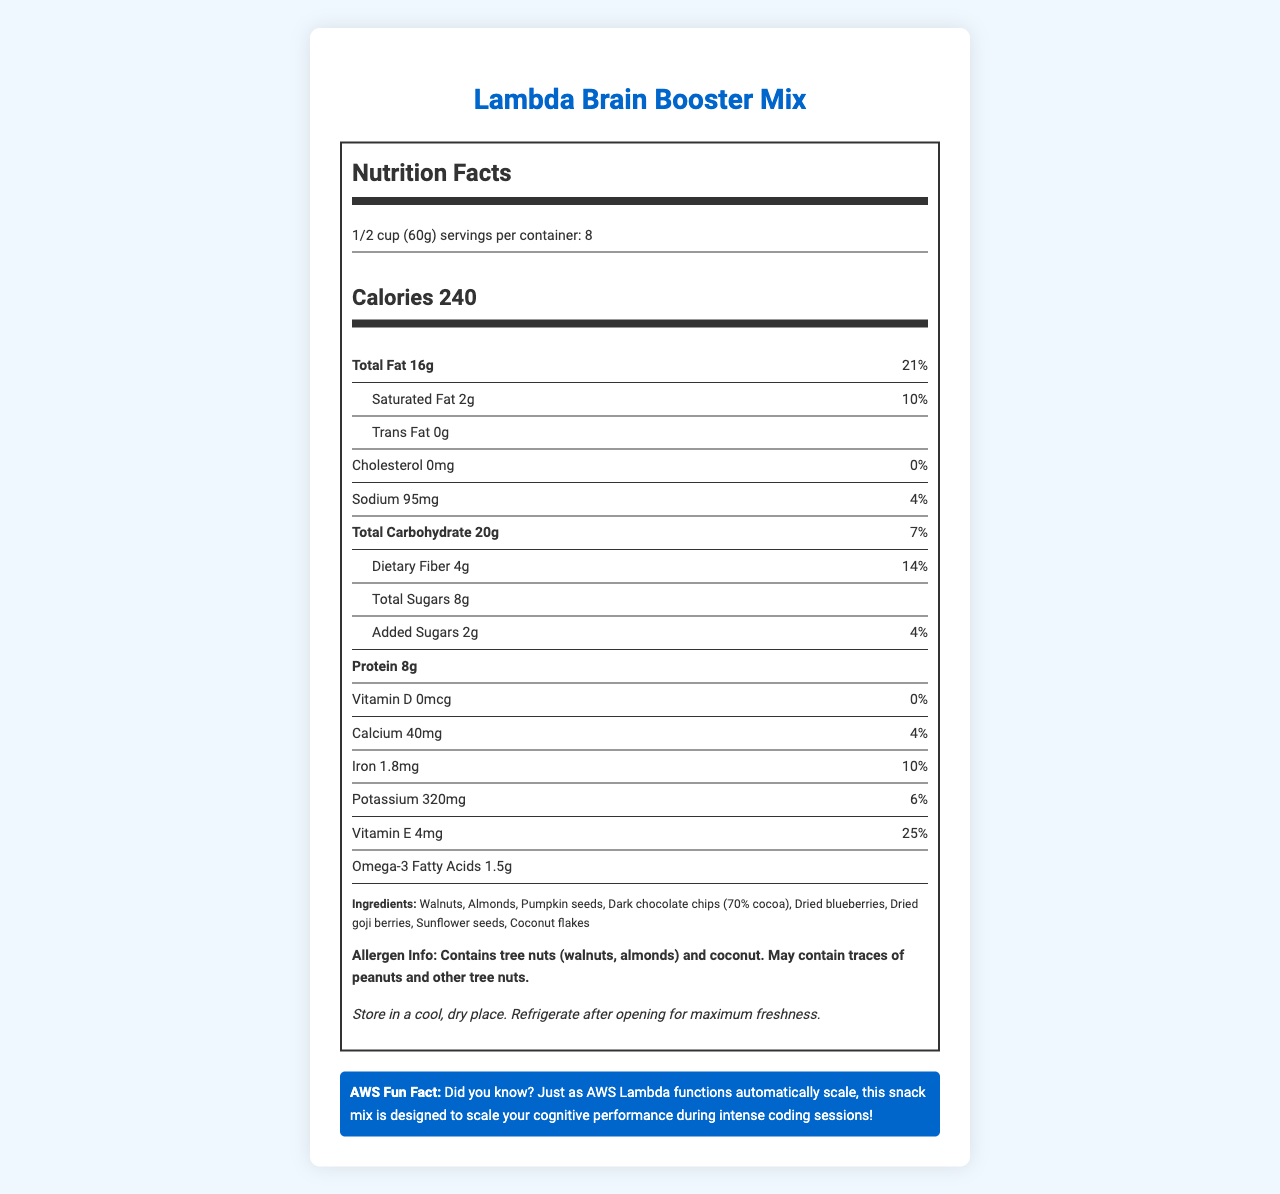what is the serving size and how many servings are in the container? The serving size is indicated as 1/2 cup (60g) and the number of servings per container is 8.
Answer: 1/2 cup (60g), 8 servings how many calories are in one serving? The calorie count is listed directly under the serving information as 240 calories.
Answer: 240 what is the total fat content per serving, and what percentage of the daily value does it represent? The document states that each serving contains 16g of total fat, which is 21% of the daily value.
Answer: 16g, 21% how much protein does each serving of the mix provide? The amount of protein per serving is listed as 8g.
Answer: 8g which of the following is an ingredient in the Lambda Brain Booster Mix? A. Peanuts B. Cashews C. Dark chocolate chips D. Raisins Among the listed ingredients, dark chocolate chips are included, while peanuts, cashews, and raisins are not.
Answer: C. Dark chocolate chips how much vitamin D is in each serving, expressed in mcg and daily value percentage? The document indicates 0mcg of vitamin D and 0% of the daily value per serving.
Answer: 0mcg, 0% does the mix contain any cholesterol? The cholesterol content is listed as 0mg, with 0% of the daily value, indicating no cholesterol.
Answer: No what allergens are present in the Lambda Brain Booster Mix? The allergen information states the mix contains tree nuts (walnuts, almonds) and coconut, and may contain traces of peanuts and other tree nuts.
Answer: Tree nuts (walnuts, almonds) and coconut. May contain traces of peanuts and other tree nuts. where should the snack mix be stored for maximum freshness after opening? Storage instructions specify to refrigerate after opening for maximum freshness.
Answer: Refrigerate how much dietary fiber does one serving of the mix provide? A. 2g B. 4g C. 6g D. 8g Each serving provides 4g of dietary fiber, as stated in the nutrition information.
Answer: B. 4g is the following statement true or false? "The snack mix provides a significant amount of omega-3 fatty acids." The mix provides 1.5g of omega-3 fatty acids, which is generally considered a good amount.
Answer: True summarize the main nutritional highlights of the Lambda Brain Booster Mix. The summary captures the key nutritional elements and storage instructions, emphasizing its cognitive benefits and major nutrients.
Answer: The Lambda Brain Booster Mix is a nutrient-rich snack designed to enhance cognitive performance, providing 240 calories per serving, including 16g of total fat, 8g of protein, 20g of carbohydrates including 4g of dietary fiber and 8g of total sugars. The mix is a good source of vitamin E (25% DV), iron (10% DV), and contains omega-3 fatty acids (1.5g). It includes ingredients like walnuts, almonds, pumpkin seeds, and dark chocolate chips, and should be refrigerated after opening. what was the specific rationale behind formulating the mix with these ingredients? The document lists the ingredients and nutritional information but does not provide specific details on the rationale behind the ingredient selection.
Answer: Cannot be determined 